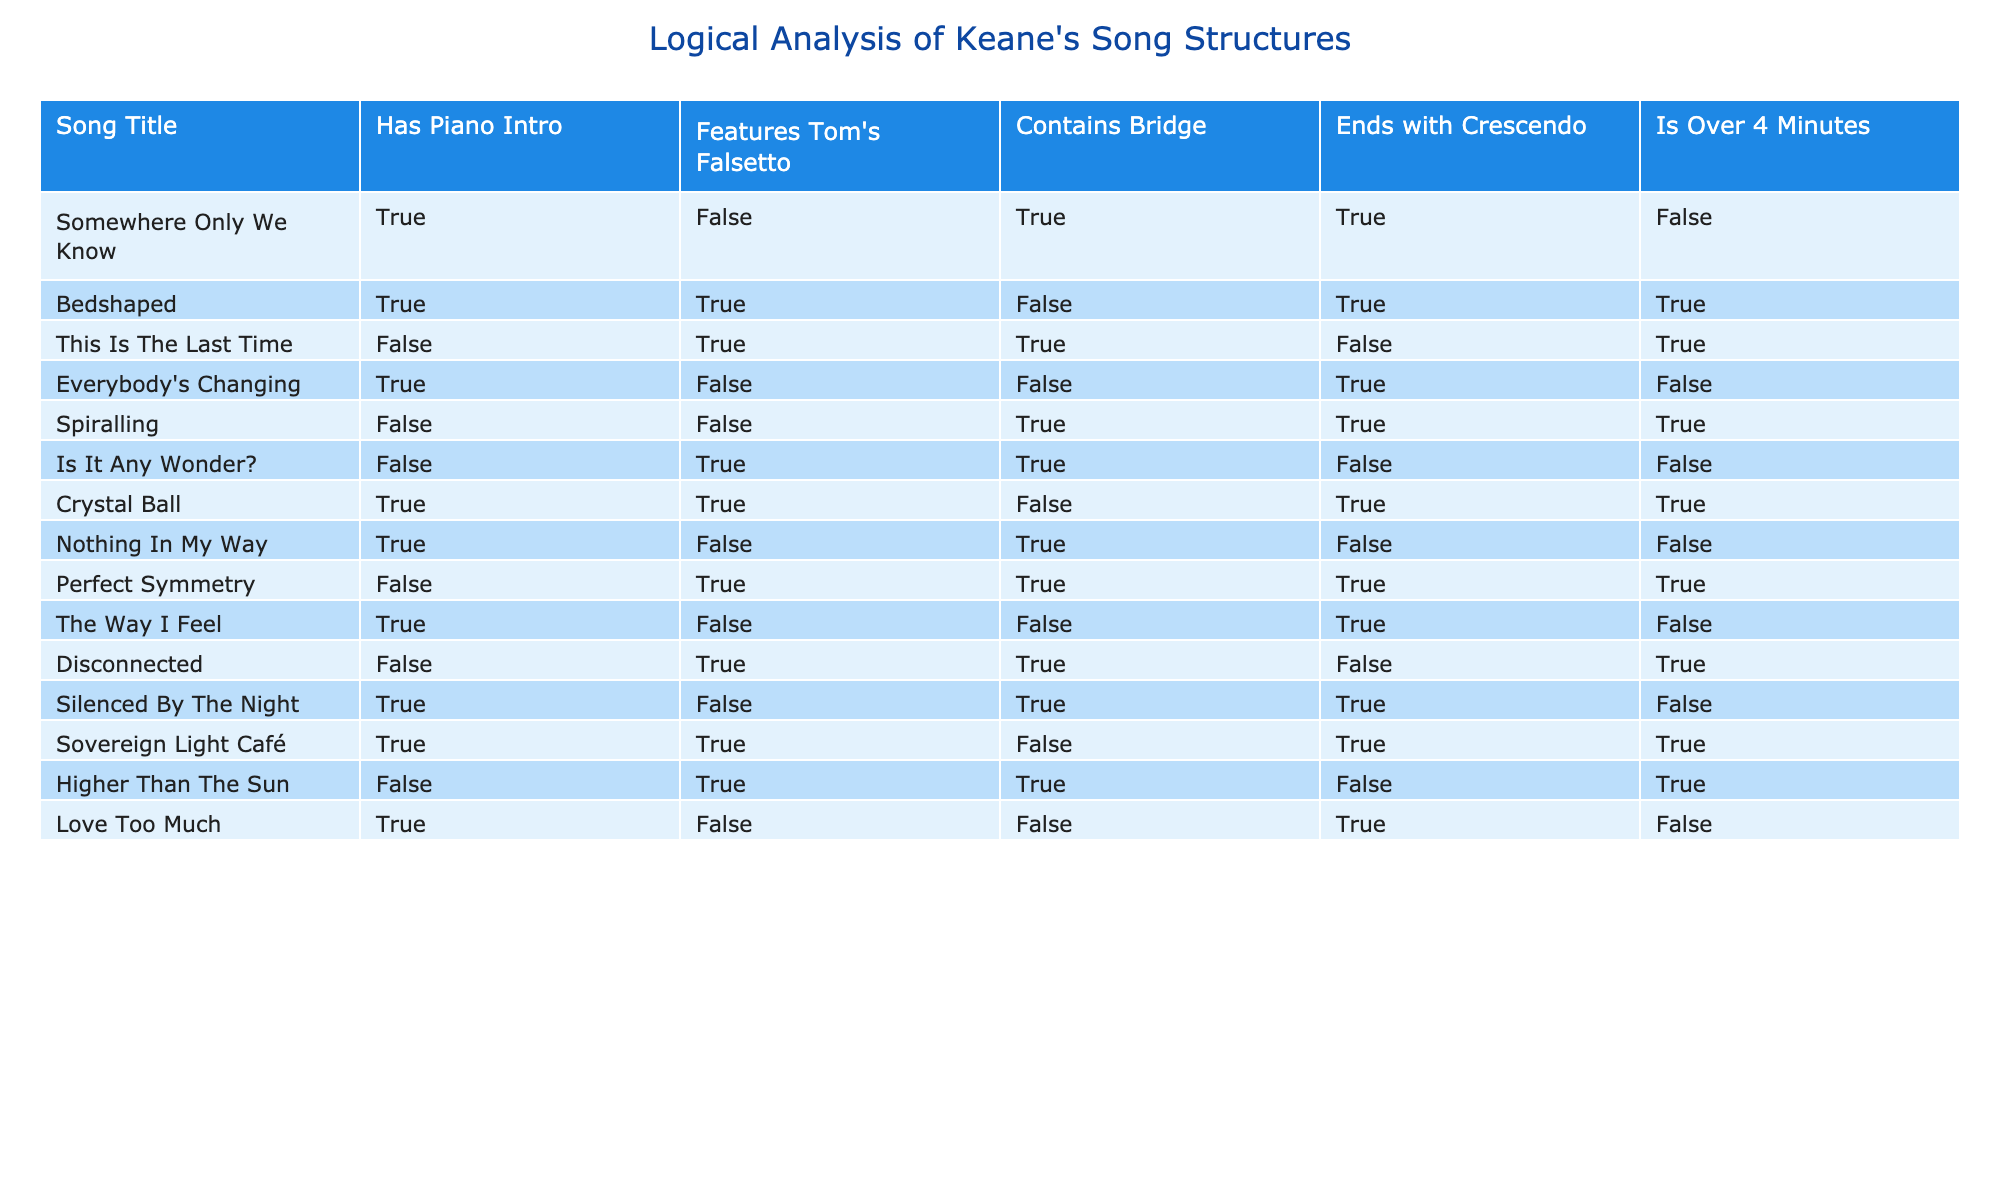What songs have a piano intro and are over 4 minutes long? From the table, we can filter the songs that have "true" under both the "Has Piano Intro" and "Is Over 4 Minutes" columns. The songs that meet this criteria are "Bedshaped" and "Perfect Symmetry".
Answer: Bedshaped, Perfect Symmetry Which song features Tom's falsetto and ends with a crescendo? Looking at the table, we need to find songs that have "true" under both "Features Tom's Falsetto" and "Ends with Crescendo". The songs that fulfill these conditions are "Spiralling" and "Silenced By The Night".
Answer: Spiralling, Silenced By The Night How many songs are over 4 minutes long? We can count the number of songs that have "true" in the "Is Over 4 Minutes" column. Upon review, we see that there are 5 songs that meet this criterion: "This Is The Last Time", "Perfect Symmetry", "Spiralling", "Higher Than The Sun", and "Sovereign Light Café".
Answer: 5 Is "Everybody's Changing" over 4 minutes long? Looking at the row for "Everybody's Changing", the "Is Over 4 Minutes" column indicates "false". Therefore, it is not over 4 minutes long.
Answer: No What percentage of songs contain a bridge? To find the percentage, we first count the total number of songs (which is 14). Next, we count how many songs contain a bridge (the "Contains Bridge" column shows "true" for 6 songs). The percentage is calculated as (6/14) * 100 = approximately 42.86%.
Answer: 42.86% How many songs have both a piano intro and a bridge? We check which songs have "true" under both "Has Piano Intro" and "Contains Bridge". Upon reviewing the table, we find that "Somewhere Only We Know", "Spiralling", and "Perfect Symmetry" meet this criteria, totaling 3 songs.
Answer: 3 Which song does not feature Tom's falsetto but ends with a crescendo? From the table, we can see the rows where "Features Tom's Falsetto" is "false" and "Ends with Crescendo" is "true". The song that meets these criteria is "Somewhere Only We Know".
Answer: Somewhere Only We Know How many songs feature Tom's falsetto and are exactly 4 minutes long? None of the songs in the table specifically address a length of exactly 4 minutes. Therefore, we can conclude there are no songs that fit this particular criterion.
Answer: 0 Are there any songs that contain a bridge but do not end with a crescendo? Reviewing the table, we see that the songs "This Is The Last Time", "Is It Any Wonder?", and "Nothing In My Way" contain a bridge but do not end with a crescendo.
Answer: Yes 